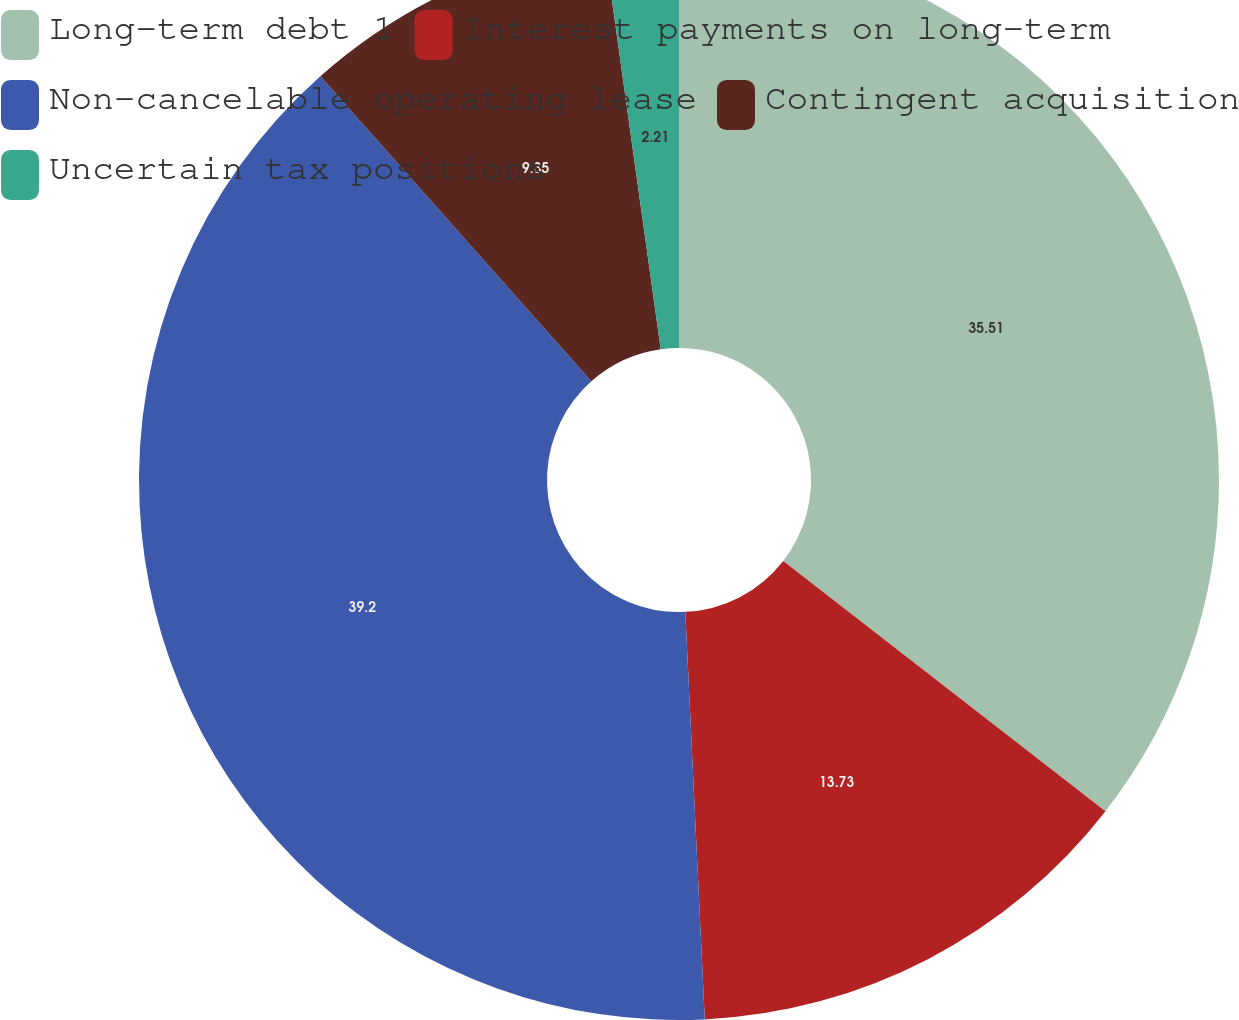<chart> <loc_0><loc_0><loc_500><loc_500><pie_chart><fcel>Long-term debt 1<fcel>Interest payments on long-term<fcel>Non-cancelable operating lease<fcel>Contingent acquisition<fcel>Uncertain tax positions<nl><fcel>35.51%<fcel>13.73%<fcel>39.2%<fcel>9.35%<fcel>2.21%<nl></chart> 